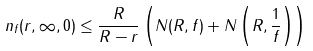Convert formula to latex. <formula><loc_0><loc_0><loc_500><loc_500>n _ { f } ( r , \infty , 0 ) \leq \frac { R } { R - r } \left ( N ( R , f ) + N \left ( R , \frac { 1 } { f } \right ) \right )</formula> 